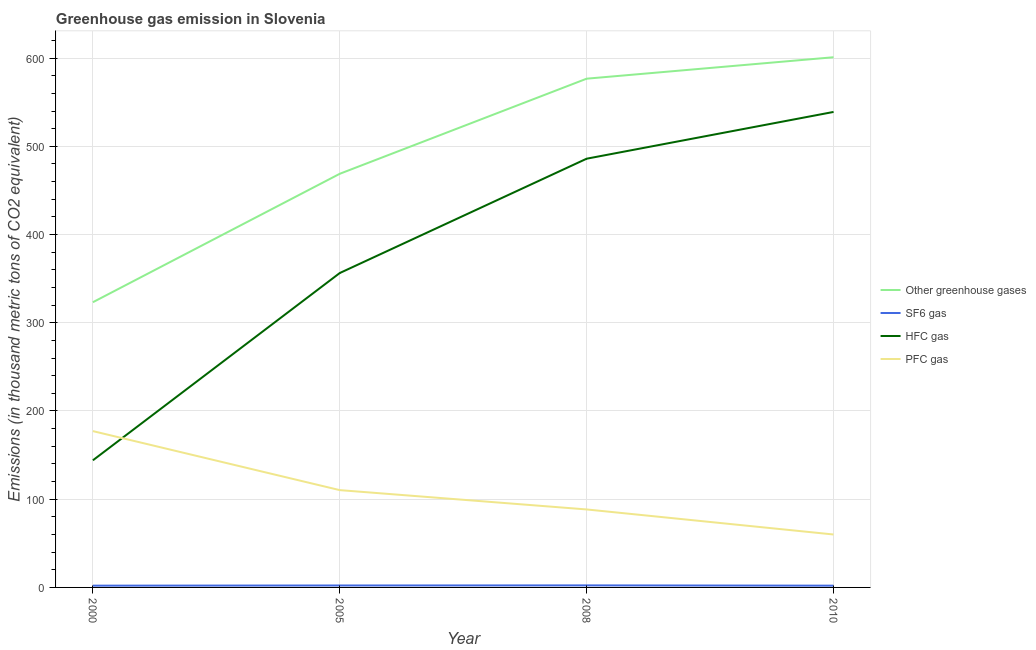Does the line corresponding to emission of hfc gas intersect with the line corresponding to emission of greenhouse gases?
Your response must be concise. No. Across all years, what is the maximum emission of sf6 gas?
Your answer should be very brief. 2.3. Across all years, what is the minimum emission of hfc gas?
Your response must be concise. 144.1. In which year was the emission of pfc gas minimum?
Give a very brief answer. 2010. What is the total emission of pfc gas in the graph?
Make the answer very short. 435.9. What is the difference between the emission of pfc gas in 2005 and that in 2010?
Keep it short and to the point. 50.3. What is the difference between the emission of sf6 gas in 2005 and the emission of hfc gas in 2010?
Give a very brief answer. -536.8. What is the average emission of greenhouse gases per year?
Provide a succinct answer. 492.48. In the year 2008, what is the difference between the emission of pfc gas and emission of sf6 gas?
Give a very brief answer. 86.1. In how many years, is the emission of hfc gas greater than 380 thousand metric tons?
Your answer should be compact. 2. What is the ratio of the emission of hfc gas in 2005 to that in 2010?
Offer a terse response. 0.66. Is the difference between the emission of greenhouse gases in 2000 and 2010 greater than the difference between the emission of hfc gas in 2000 and 2010?
Offer a terse response. Yes. What is the difference between the highest and the second highest emission of sf6 gas?
Give a very brief answer. 0.1. What is the difference between the highest and the lowest emission of hfc gas?
Your response must be concise. 394.9. Is it the case that in every year, the sum of the emission of hfc gas and emission of greenhouse gases is greater than the sum of emission of pfc gas and emission of sf6 gas?
Your answer should be very brief. No. Is it the case that in every year, the sum of the emission of greenhouse gases and emission of sf6 gas is greater than the emission of hfc gas?
Offer a terse response. Yes. How many lines are there?
Ensure brevity in your answer.  4. Where does the legend appear in the graph?
Offer a terse response. Center right. How are the legend labels stacked?
Make the answer very short. Vertical. What is the title of the graph?
Provide a succinct answer. Greenhouse gas emission in Slovenia. What is the label or title of the Y-axis?
Keep it short and to the point. Emissions (in thousand metric tons of CO2 equivalent). What is the Emissions (in thousand metric tons of CO2 equivalent) of Other greenhouse gases in 2000?
Your answer should be compact. 323.3. What is the Emissions (in thousand metric tons of CO2 equivalent) of HFC gas in 2000?
Provide a succinct answer. 144.1. What is the Emissions (in thousand metric tons of CO2 equivalent) in PFC gas in 2000?
Your response must be concise. 177.2. What is the Emissions (in thousand metric tons of CO2 equivalent) of Other greenhouse gases in 2005?
Provide a short and direct response. 468.9. What is the Emissions (in thousand metric tons of CO2 equivalent) in SF6 gas in 2005?
Keep it short and to the point. 2.2. What is the Emissions (in thousand metric tons of CO2 equivalent) in HFC gas in 2005?
Ensure brevity in your answer.  356.4. What is the Emissions (in thousand metric tons of CO2 equivalent) of PFC gas in 2005?
Give a very brief answer. 110.3. What is the Emissions (in thousand metric tons of CO2 equivalent) of Other greenhouse gases in 2008?
Your answer should be compact. 576.7. What is the Emissions (in thousand metric tons of CO2 equivalent) in SF6 gas in 2008?
Your answer should be very brief. 2.3. What is the Emissions (in thousand metric tons of CO2 equivalent) of HFC gas in 2008?
Your answer should be very brief. 486. What is the Emissions (in thousand metric tons of CO2 equivalent) in PFC gas in 2008?
Offer a very short reply. 88.4. What is the Emissions (in thousand metric tons of CO2 equivalent) in Other greenhouse gases in 2010?
Your response must be concise. 601. What is the Emissions (in thousand metric tons of CO2 equivalent) in HFC gas in 2010?
Make the answer very short. 539. Across all years, what is the maximum Emissions (in thousand metric tons of CO2 equivalent) of Other greenhouse gases?
Keep it short and to the point. 601. Across all years, what is the maximum Emissions (in thousand metric tons of CO2 equivalent) of SF6 gas?
Provide a short and direct response. 2.3. Across all years, what is the maximum Emissions (in thousand metric tons of CO2 equivalent) of HFC gas?
Keep it short and to the point. 539. Across all years, what is the maximum Emissions (in thousand metric tons of CO2 equivalent) of PFC gas?
Ensure brevity in your answer.  177.2. Across all years, what is the minimum Emissions (in thousand metric tons of CO2 equivalent) of Other greenhouse gases?
Your answer should be compact. 323.3. Across all years, what is the minimum Emissions (in thousand metric tons of CO2 equivalent) of HFC gas?
Your answer should be compact. 144.1. What is the total Emissions (in thousand metric tons of CO2 equivalent) of Other greenhouse gases in the graph?
Keep it short and to the point. 1969.9. What is the total Emissions (in thousand metric tons of CO2 equivalent) of HFC gas in the graph?
Provide a short and direct response. 1525.5. What is the total Emissions (in thousand metric tons of CO2 equivalent) in PFC gas in the graph?
Your answer should be compact. 435.9. What is the difference between the Emissions (in thousand metric tons of CO2 equivalent) in Other greenhouse gases in 2000 and that in 2005?
Make the answer very short. -145.6. What is the difference between the Emissions (in thousand metric tons of CO2 equivalent) of SF6 gas in 2000 and that in 2005?
Make the answer very short. -0.2. What is the difference between the Emissions (in thousand metric tons of CO2 equivalent) in HFC gas in 2000 and that in 2005?
Provide a short and direct response. -212.3. What is the difference between the Emissions (in thousand metric tons of CO2 equivalent) of PFC gas in 2000 and that in 2005?
Your answer should be compact. 66.9. What is the difference between the Emissions (in thousand metric tons of CO2 equivalent) of Other greenhouse gases in 2000 and that in 2008?
Your response must be concise. -253.4. What is the difference between the Emissions (in thousand metric tons of CO2 equivalent) in SF6 gas in 2000 and that in 2008?
Make the answer very short. -0.3. What is the difference between the Emissions (in thousand metric tons of CO2 equivalent) in HFC gas in 2000 and that in 2008?
Give a very brief answer. -341.9. What is the difference between the Emissions (in thousand metric tons of CO2 equivalent) of PFC gas in 2000 and that in 2008?
Give a very brief answer. 88.8. What is the difference between the Emissions (in thousand metric tons of CO2 equivalent) of Other greenhouse gases in 2000 and that in 2010?
Provide a short and direct response. -277.7. What is the difference between the Emissions (in thousand metric tons of CO2 equivalent) of HFC gas in 2000 and that in 2010?
Your answer should be very brief. -394.9. What is the difference between the Emissions (in thousand metric tons of CO2 equivalent) in PFC gas in 2000 and that in 2010?
Keep it short and to the point. 117.2. What is the difference between the Emissions (in thousand metric tons of CO2 equivalent) of Other greenhouse gases in 2005 and that in 2008?
Give a very brief answer. -107.8. What is the difference between the Emissions (in thousand metric tons of CO2 equivalent) of SF6 gas in 2005 and that in 2008?
Your answer should be very brief. -0.1. What is the difference between the Emissions (in thousand metric tons of CO2 equivalent) in HFC gas in 2005 and that in 2008?
Keep it short and to the point. -129.6. What is the difference between the Emissions (in thousand metric tons of CO2 equivalent) in PFC gas in 2005 and that in 2008?
Offer a terse response. 21.9. What is the difference between the Emissions (in thousand metric tons of CO2 equivalent) in Other greenhouse gases in 2005 and that in 2010?
Your answer should be compact. -132.1. What is the difference between the Emissions (in thousand metric tons of CO2 equivalent) of SF6 gas in 2005 and that in 2010?
Ensure brevity in your answer.  0.2. What is the difference between the Emissions (in thousand metric tons of CO2 equivalent) of HFC gas in 2005 and that in 2010?
Provide a succinct answer. -182.6. What is the difference between the Emissions (in thousand metric tons of CO2 equivalent) of PFC gas in 2005 and that in 2010?
Give a very brief answer. 50.3. What is the difference between the Emissions (in thousand metric tons of CO2 equivalent) of Other greenhouse gases in 2008 and that in 2010?
Provide a short and direct response. -24.3. What is the difference between the Emissions (in thousand metric tons of CO2 equivalent) of SF6 gas in 2008 and that in 2010?
Ensure brevity in your answer.  0.3. What is the difference between the Emissions (in thousand metric tons of CO2 equivalent) in HFC gas in 2008 and that in 2010?
Make the answer very short. -53. What is the difference between the Emissions (in thousand metric tons of CO2 equivalent) in PFC gas in 2008 and that in 2010?
Give a very brief answer. 28.4. What is the difference between the Emissions (in thousand metric tons of CO2 equivalent) in Other greenhouse gases in 2000 and the Emissions (in thousand metric tons of CO2 equivalent) in SF6 gas in 2005?
Provide a succinct answer. 321.1. What is the difference between the Emissions (in thousand metric tons of CO2 equivalent) of Other greenhouse gases in 2000 and the Emissions (in thousand metric tons of CO2 equivalent) of HFC gas in 2005?
Your answer should be very brief. -33.1. What is the difference between the Emissions (in thousand metric tons of CO2 equivalent) of Other greenhouse gases in 2000 and the Emissions (in thousand metric tons of CO2 equivalent) of PFC gas in 2005?
Provide a succinct answer. 213. What is the difference between the Emissions (in thousand metric tons of CO2 equivalent) of SF6 gas in 2000 and the Emissions (in thousand metric tons of CO2 equivalent) of HFC gas in 2005?
Your answer should be very brief. -354.4. What is the difference between the Emissions (in thousand metric tons of CO2 equivalent) of SF6 gas in 2000 and the Emissions (in thousand metric tons of CO2 equivalent) of PFC gas in 2005?
Provide a short and direct response. -108.3. What is the difference between the Emissions (in thousand metric tons of CO2 equivalent) in HFC gas in 2000 and the Emissions (in thousand metric tons of CO2 equivalent) in PFC gas in 2005?
Offer a terse response. 33.8. What is the difference between the Emissions (in thousand metric tons of CO2 equivalent) of Other greenhouse gases in 2000 and the Emissions (in thousand metric tons of CO2 equivalent) of SF6 gas in 2008?
Keep it short and to the point. 321. What is the difference between the Emissions (in thousand metric tons of CO2 equivalent) of Other greenhouse gases in 2000 and the Emissions (in thousand metric tons of CO2 equivalent) of HFC gas in 2008?
Offer a terse response. -162.7. What is the difference between the Emissions (in thousand metric tons of CO2 equivalent) of Other greenhouse gases in 2000 and the Emissions (in thousand metric tons of CO2 equivalent) of PFC gas in 2008?
Provide a succinct answer. 234.9. What is the difference between the Emissions (in thousand metric tons of CO2 equivalent) of SF6 gas in 2000 and the Emissions (in thousand metric tons of CO2 equivalent) of HFC gas in 2008?
Provide a succinct answer. -484. What is the difference between the Emissions (in thousand metric tons of CO2 equivalent) of SF6 gas in 2000 and the Emissions (in thousand metric tons of CO2 equivalent) of PFC gas in 2008?
Keep it short and to the point. -86.4. What is the difference between the Emissions (in thousand metric tons of CO2 equivalent) of HFC gas in 2000 and the Emissions (in thousand metric tons of CO2 equivalent) of PFC gas in 2008?
Your answer should be compact. 55.7. What is the difference between the Emissions (in thousand metric tons of CO2 equivalent) of Other greenhouse gases in 2000 and the Emissions (in thousand metric tons of CO2 equivalent) of SF6 gas in 2010?
Your response must be concise. 321.3. What is the difference between the Emissions (in thousand metric tons of CO2 equivalent) in Other greenhouse gases in 2000 and the Emissions (in thousand metric tons of CO2 equivalent) in HFC gas in 2010?
Keep it short and to the point. -215.7. What is the difference between the Emissions (in thousand metric tons of CO2 equivalent) in Other greenhouse gases in 2000 and the Emissions (in thousand metric tons of CO2 equivalent) in PFC gas in 2010?
Keep it short and to the point. 263.3. What is the difference between the Emissions (in thousand metric tons of CO2 equivalent) in SF6 gas in 2000 and the Emissions (in thousand metric tons of CO2 equivalent) in HFC gas in 2010?
Your answer should be very brief. -537. What is the difference between the Emissions (in thousand metric tons of CO2 equivalent) of SF6 gas in 2000 and the Emissions (in thousand metric tons of CO2 equivalent) of PFC gas in 2010?
Provide a short and direct response. -58. What is the difference between the Emissions (in thousand metric tons of CO2 equivalent) in HFC gas in 2000 and the Emissions (in thousand metric tons of CO2 equivalent) in PFC gas in 2010?
Offer a terse response. 84.1. What is the difference between the Emissions (in thousand metric tons of CO2 equivalent) in Other greenhouse gases in 2005 and the Emissions (in thousand metric tons of CO2 equivalent) in SF6 gas in 2008?
Give a very brief answer. 466.6. What is the difference between the Emissions (in thousand metric tons of CO2 equivalent) of Other greenhouse gases in 2005 and the Emissions (in thousand metric tons of CO2 equivalent) of HFC gas in 2008?
Offer a very short reply. -17.1. What is the difference between the Emissions (in thousand metric tons of CO2 equivalent) in Other greenhouse gases in 2005 and the Emissions (in thousand metric tons of CO2 equivalent) in PFC gas in 2008?
Your answer should be compact. 380.5. What is the difference between the Emissions (in thousand metric tons of CO2 equivalent) of SF6 gas in 2005 and the Emissions (in thousand metric tons of CO2 equivalent) of HFC gas in 2008?
Provide a succinct answer. -483.8. What is the difference between the Emissions (in thousand metric tons of CO2 equivalent) in SF6 gas in 2005 and the Emissions (in thousand metric tons of CO2 equivalent) in PFC gas in 2008?
Offer a very short reply. -86.2. What is the difference between the Emissions (in thousand metric tons of CO2 equivalent) of HFC gas in 2005 and the Emissions (in thousand metric tons of CO2 equivalent) of PFC gas in 2008?
Your answer should be very brief. 268. What is the difference between the Emissions (in thousand metric tons of CO2 equivalent) of Other greenhouse gases in 2005 and the Emissions (in thousand metric tons of CO2 equivalent) of SF6 gas in 2010?
Offer a terse response. 466.9. What is the difference between the Emissions (in thousand metric tons of CO2 equivalent) in Other greenhouse gases in 2005 and the Emissions (in thousand metric tons of CO2 equivalent) in HFC gas in 2010?
Your answer should be very brief. -70.1. What is the difference between the Emissions (in thousand metric tons of CO2 equivalent) in Other greenhouse gases in 2005 and the Emissions (in thousand metric tons of CO2 equivalent) in PFC gas in 2010?
Provide a short and direct response. 408.9. What is the difference between the Emissions (in thousand metric tons of CO2 equivalent) of SF6 gas in 2005 and the Emissions (in thousand metric tons of CO2 equivalent) of HFC gas in 2010?
Provide a short and direct response. -536.8. What is the difference between the Emissions (in thousand metric tons of CO2 equivalent) of SF6 gas in 2005 and the Emissions (in thousand metric tons of CO2 equivalent) of PFC gas in 2010?
Your response must be concise. -57.8. What is the difference between the Emissions (in thousand metric tons of CO2 equivalent) in HFC gas in 2005 and the Emissions (in thousand metric tons of CO2 equivalent) in PFC gas in 2010?
Keep it short and to the point. 296.4. What is the difference between the Emissions (in thousand metric tons of CO2 equivalent) in Other greenhouse gases in 2008 and the Emissions (in thousand metric tons of CO2 equivalent) in SF6 gas in 2010?
Provide a short and direct response. 574.7. What is the difference between the Emissions (in thousand metric tons of CO2 equivalent) of Other greenhouse gases in 2008 and the Emissions (in thousand metric tons of CO2 equivalent) of HFC gas in 2010?
Provide a succinct answer. 37.7. What is the difference between the Emissions (in thousand metric tons of CO2 equivalent) of Other greenhouse gases in 2008 and the Emissions (in thousand metric tons of CO2 equivalent) of PFC gas in 2010?
Provide a short and direct response. 516.7. What is the difference between the Emissions (in thousand metric tons of CO2 equivalent) of SF6 gas in 2008 and the Emissions (in thousand metric tons of CO2 equivalent) of HFC gas in 2010?
Make the answer very short. -536.7. What is the difference between the Emissions (in thousand metric tons of CO2 equivalent) of SF6 gas in 2008 and the Emissions (in thousand metric tons of CO2 equivalent) of PFC gas in 2010?
Make the answer very short. -57.7. What is the difference between the Emissions (in thousand metric tons of CO2 equivalent) of HFC gas in 2008 and the Emissions (in thousand metric tons of CO2 equivalent) of PFC gas in 2010?
Provide a short and direct response. 426. What is the average Emissions (in thousand metric tons of CO2 equivalent) in Other greenhouse gases per year?
Offer a terse response. 492.48. What is the average Emissions (in thousand metric tons of CO2 equivalent) of SF6 gas per year?
Give a very brief answer. 2.12. What is the average Emissions (in thousand metric tons of CO2 equivalent) of HFC gas per year?
Provide a short and direct response. 381.38. What is the average Emissions (in thousand metric tons of CO2 equivalent) of PFC gas per year?
Provide a short and direct response. 108.97. In the year 2000, what is the difference between the Emissions (in thousand metric tons of CO2 equivalent) of Other greenhouse gases and Emissions (in thousand metric tons of CO2 equivalent) of SF6 gas?
Provide a succinct answer. 321.3. In the year 2000, what is the difference between the Emissions (in thousand metric tons of CO2 equivalent) of Other greenhouse gases and Emissions (in thousand metric tons of CO2 equivalent) of HFC gas?
Keep it short and to the point. 179.2. In the year 2000, what is the difference between the Emissions (in thousand metric tons of CO2 equivalent) in Other greenhouse gases and Emissions (in thousand metric tons of CO2 equivalent) in PFC gas?
Provide a short and direct response. 146.1. In the year 2000, what is the difference between the Emissions (in thousand metric tons of CO2 equivalent) in SF6 gas and Emissions (in thousand metric tons of CO2 equivalent) in HFC gas?
Your answer should be compact. -142.1. In the year 2000, what is the difference between the Emissions (in thousand metric tons of CO2 equivalent) in SF6 gas and Emissions (in thousand metric tons of CO2 equivalent) in PFC gas?
Your answer should be compact. -175.2. In the year 2000, what is the difference between the Emissions (in thousand metric tons of CO2 equivalent) in HFC gas and Emissions (in thousand metric tons of CO2 equivalent) in PFC gas?
Ensure brevity in your answer.  -33.1. In the year 2005, what is the difference between the Emissions (in thousand metric tons of CO2 equivalent) of Other greenhouse gases and Emissions (in thousand metric tons of CO2 equivalent) of SF6 gas?
Your answer should be very brief. 466.7. In the year 2005, what is the difference between the Emissions (in thousand metric tons of CO2 equivalent) in Other greenhouse gases and Emissions (in thousand metric tons of CO2 equivalent) in HFC gas?
Provide a succinct answer. 112.5. In the year 2005, what is the difference between the Emissions (in thousand metric tons of CO2 equivalent) of Other greenhouse gases and Emissions (in thousand metric tons of CO2 equivalent) of PFC gas?
Your answer should be compact. 358.6. In the year 2005, what is the difference between the Emissions (in thousand metric tons of CO2 equivalent) in SF6 gas and Emissions (in thousand metric tons of CO2 equivalent) in HFC gas?
Your answer should be very brief. -354.2. In the year 2005, what is the difference between the Emissions (in thousand metric tons of CO2 equivalent) in SF6 gas and Emissions (in thousand metric tons of CO2 equivalent) in PFC gas?
Keep it short and to the point. -108.1. In the year 2005, what is the difference between the Emissions (in thousand metric tons of CO2 equivalent) in HFC gas and Emissions (in thousand metric tons of CO2 equivalent) in PFC gas?
Provide a succinct answer. 246.1. In the year 2008, what is the difference between the Emissions (in thousand metric tons of CO2 equivalent) of Other greenhouse gases and Emissions (in thousand metric tons of CO2 equivalent) of SF6 gas?
Your answer should be compact. 574.4. In the year 2008, what is the difference between the Emissions (in thousand metric tons of CO2 equivalent) in Other greenhouse gases and Emissions (in thousand metric tons of CO2 equivalent) in HFC gas?
Your response must be concise. 90.7. In the year 2008, what is the difference between the Emissions (in thousand metric tons of CO2 equivalent) of Other greenhouse gases and Emissions (in thousand metric tons of CO2 equivalent) of PFC gas?
Your response must be concise. 488.3. In the year 2008, what is the difference between the Emissions (in thousand metric tons of CO2 equivalent) in SF6 gas and Emissions (in thousand metric tons of CO2 equivalent) in HFC gas?
Provide a short and direct response. -483.7. In the year 2008, what is the difference between the Emissions (in thousand metric tons of CO2 equivalent) in SF6 gas and Emissions (in thousand metric tons of CO2 equivalent) in PFC gas?
Your response must be concise. -86.1. In the year 2008, what is the difference between the Emissions (in thousand metric tons of CO2 equivalent) of HFC gas and Emissions (in thousand metric tons of CO2 equivalent) of PFC gas?
Make the answer very short. 397.6. In the year 2010, what is the difference between the Emissions (in thousand metric tons of CO2 equivalent) of Other greenhouse gases and Emissions (in thousand metric tons of CO2 equivalent) of SF6 gas?
Provide a short and direct response. 599. In the year 2010, what is the difference between the Emissions (in thousand metric tons of CO2 equivalent) of Other greenhouse gases and Emissions (in thousand metric tons of CO2 equivalent) of HFC gas?
Provide a succinct answer. 62. In the year 2010, what is the difference between the Emissions (in thousand metric tons of CO2 equivalent) in Other greenhouse gases and Emissions (in thousand metric tons of CO2 equivalent) in PFC gas?
Give a very brief answer. 541. In the year 2010, what is the difference between the Emissions (in thousand metric tons of CO2 equivalent) of SF6 gas and Emissions (in thousand metric tons of CO2 equivalent) of HFC gas?
Your response must be concise. -537. In the year 2010, what is the difference between the Emissions (in thousand metric tons of CO2 equivalent) in SF6 gas and Emissions (in thousand metric tons of CO2 equivalent) in PFC gas?
Provide a succinct answer. -58. In the year 2010, what is the difference between the Emissions (in thousand metric tons of CO2 equivalent) in HFC gas and Emissions (in thousand metric tons of CO2 equivalent) in PFC gas?
Provide a short and direct response. 479. What is the ratio of the Emissions (in thousand metric tons of CO2 equivalent) in Other greenhouse gases in 2000 to that in 2005?
Offer a terse response. 0.69. What is the ratio of the Emissions (in thousand metric tons of CO2 equivalent) in HFC gas in 2000 to that in 2005?
Offer a terse response. 0.4. What is the ratio of the Emissions (in thousand metric tons of CO2 equivalent) of PFC gas in 2000 to that in 2005?
Ensure brevity in your answer.  1.61. What is the ratio of the Emissions (in thousand metric tons of CO2 equivalent) of Other greenhouse gases in 2000 to that in 2008?
Give a very brief answer. 0.56. What is the ratio of the Emissions (in thousand metric tons of CO2 equivalent) in SF6 gas in 2000 to that in 2008?
Make the answer very short. 0.87. What is the ratio of the Emissions (in thousand metric tons of CO2 equivalent) in HFC gas in 2000 to that in 2008?
Offer a very short reply. 0.3. What is the ratio of the Emissions (in thousand metric tons of CO2 equivalent) in PFC gas in 2000 to that in 2008?
Your answer should be compact. 2. What is the ratio of the Emissions (in thousand metric tons of CO2 equivalent) in Other greenhouse gases in 2000 to that in 2010?
Offer a terse response. 0.54. What is the ratio of the Emissions (in thousand metric tons of CO2 equivalent) of HFC gas in 2000 to that in 2010?
Make the answer very short. 0.27. What is the ratio of the Emissions (in thousand metric tons of CO2 equivalent) in PFC gas in 2000 to that in 2010?
Your answer should be compact. 2.95. What is the ratio of the Emissions (in thousand metric tons of CO2 equivalent) of Other greenhouse gases in 2005 to that in 2008?
Provide a succinct answer. 0.81. What is the ratio of the Emissions (in thousand metric tons of CO2 equivalent) in SF6 gas in 2005 to that in 2008?
Your answer should be compact. 0.96. What is the ratio of the Emissions (in thousand metric tons of CO2 equivalent) of HFC gas in 2005 to that in 2008?
Keep it short and to the point. 0.73. What is the ratio of the Emissions (in thousand metric tons of CO2 equivalent) of PFC gas in 2005 to that in 2008?
Offer a very short reply. 1.25. What is the ratio of the Emissions (in thousand metric tons of CO2 equivalent) in Other greenhouse gases in 2005 to that in 2010?
Provide a succinct answer. 0.78. What is the ratio of the Emissions (in thousand metric tons of CO2 equivalent) in SF6 gas in 2005 to that in 2010?
Give a very brief answer. 1.1. What is the ratio of the Emissions (in thousand metric tons of CO2 equivalent) of HFC gas in 2005 to that in 2010?
Provide a succinct answer. 0.66. What is the ratio of the Emissions (in thousand metric tons of CO2 equivalent) in PFC gas in 2005 to that in 2010?
Offer a terse response. 1.84. What is the ratio of the Emissions (in thousand metric tons of CO2 equivalent) of Other greenhouse gases in 2008 to that in 2010?
Offer a terse response. 0.96. What is the ratio of the Emissions (in thousand metric tons of CO2 equivalent) of SF6 gas in 2008 to that in 2010?
Offer a very short reply. 1.15. What is the ratio of the Emissions (in thousand metric tons of CO2 equivalent) in HFC gas in 2008 to that in 2010?
Provide a short and direct response. 0.9. What is the ratio of the Emissions (in thousand metric tons of CO2 equivalent) in PFC gas in 2008 to that in 2010?
Offer a very short reply. 1.47. What is the difference between the highest and the second highest Emissions (in thousand metric tons of CO2 equivalent) of Other greenhouse gases?
Your answer should be compact. 24.3. What is the difference between the highest and the second highest Emissions (in thousand metric tons of CO2 equivalent) in SF6 gas?
Ensure brevity in your answer.  0.1. What is the difference between the highest and the second highest Emissions (in thousand metric tons of CO2 equivalent) in PFC gas?
Keep it short and to the point. 66.9. What is the difference between the highest and the lowest Emissions (in thousand metric tons of CO2 equivalent) in Other greenhouse gases?
Give a very brief answer. 277.7. What is the difference between the highest and the lowest Emissions (in thousand metric tons of CO2 equivalent) in SF6 gas?
Your response must be concise. 0.3. What is the difference between the highest and the lowest Emissions (in thousand metric tons of CO2 equivalent) in HFC gas?
Provide a short and direct response. 394.9. What is the difference between the highest and the lowest Emissions (in thousand metric tons of CO2 equivalent) in PFC gas?
Provide a succinct answer. 117.2. 